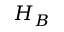Convert formula to latex. <formula><loc_0><loc_0><loc_500><loc_500>H _ { B }</formula> 